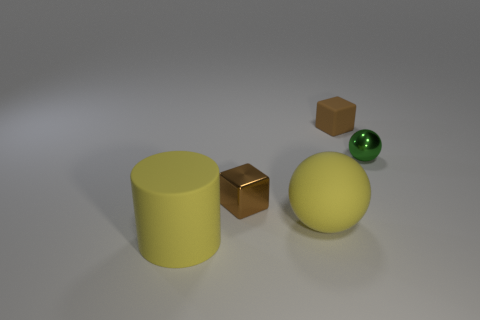Add 2 tiny brown matte cubes. How many objects exist? 7 Subtract all cylinders. How many objects are left? 4 Subtract all tiny things. Subtract all green metal balls. How many objects are left? 1 Add 5 tiny green things. How many tiny green things are left? 6 Add 1 small brown rubber blocks. How many small brown rubber blocks exist? 2 Subtract 1 yellow cylinders. How many objects are left? 4 